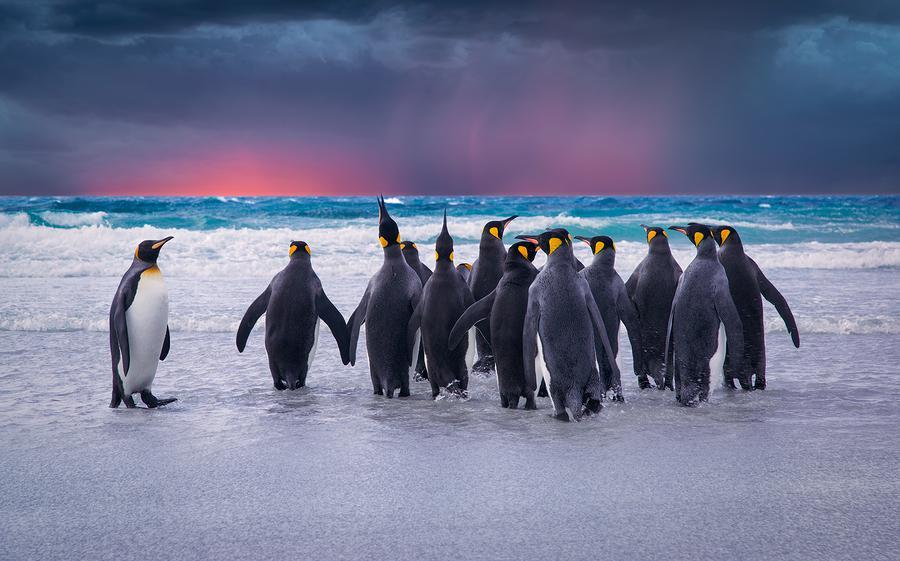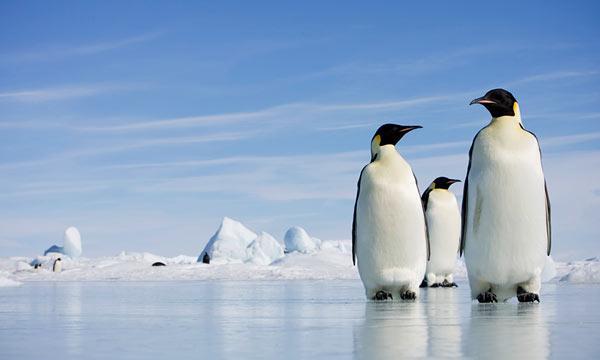The first image is the image on the left, the second image is the image on the right. Considering the images on both sides, is "There is at least one image containing only two penguins." valid? Answer yes or no. No. The first image is the image on the left, the second image is the image on the right. For the images displayed, is the sentence "There are two penguins standing together in the left image." factually correct? Answer yes or no. No. 